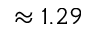<formula> <loc_0><loc_0><loc_500><loc_500>\approx 1 . 2 9</formula> 